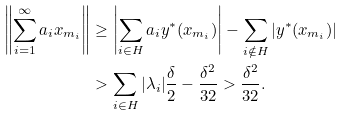Convert formula to latex. <formula><loc_0><loc_0><loc_500><loc_500>\left \| \sum _ { i = 1 } ^ { \infty } a _ { i } x _ { m _ { i } } \right \| & \geq \left | \sum _ { i \in H } a _ { i } y ^ { * } ( x _ { m _ { i } } ) \right | - \sum _ { i \notin H } | y ^ { * } ( x _ { m _ { i } } ) | \\ & > \sum _ { i \in H } | { \lambda } _ { i } | \frac { \delta } { 2 } - \frac { { \delta } ^ { 2 } } { 3 2 } > \frac { { \delta } ^ { 2 } } { 3 2 } .</formula> 